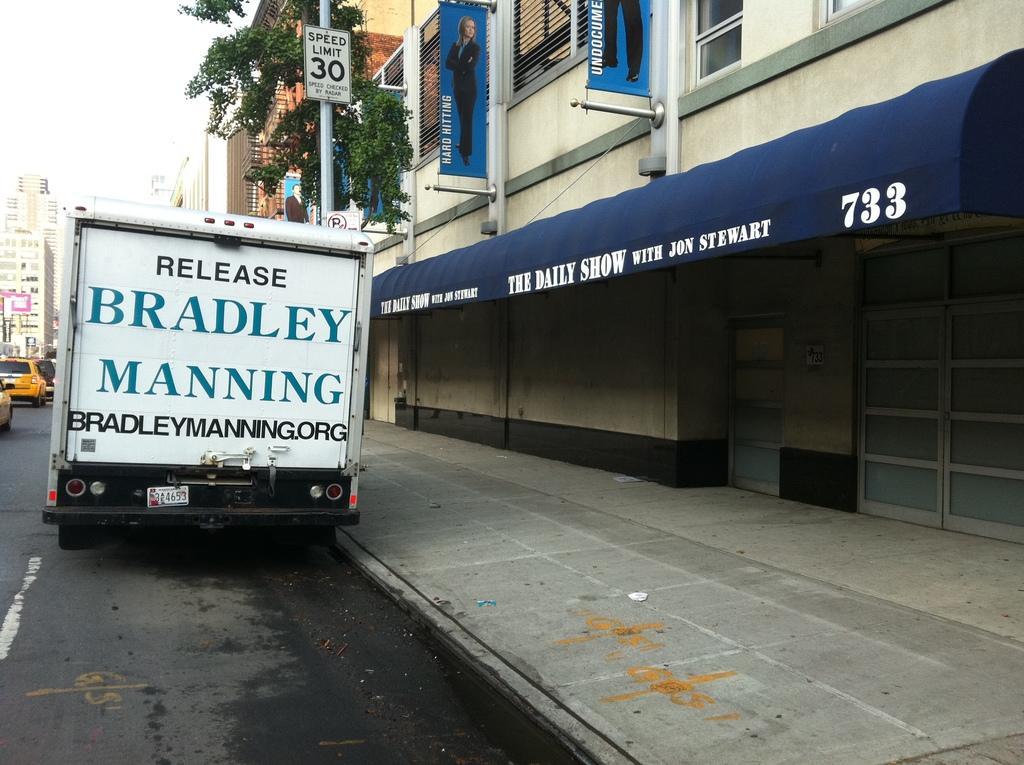Can you describe this image briefly? In the image I can see buildings, a tree, vehicles on the road and poles which has boards. In the background I can see the sky. 